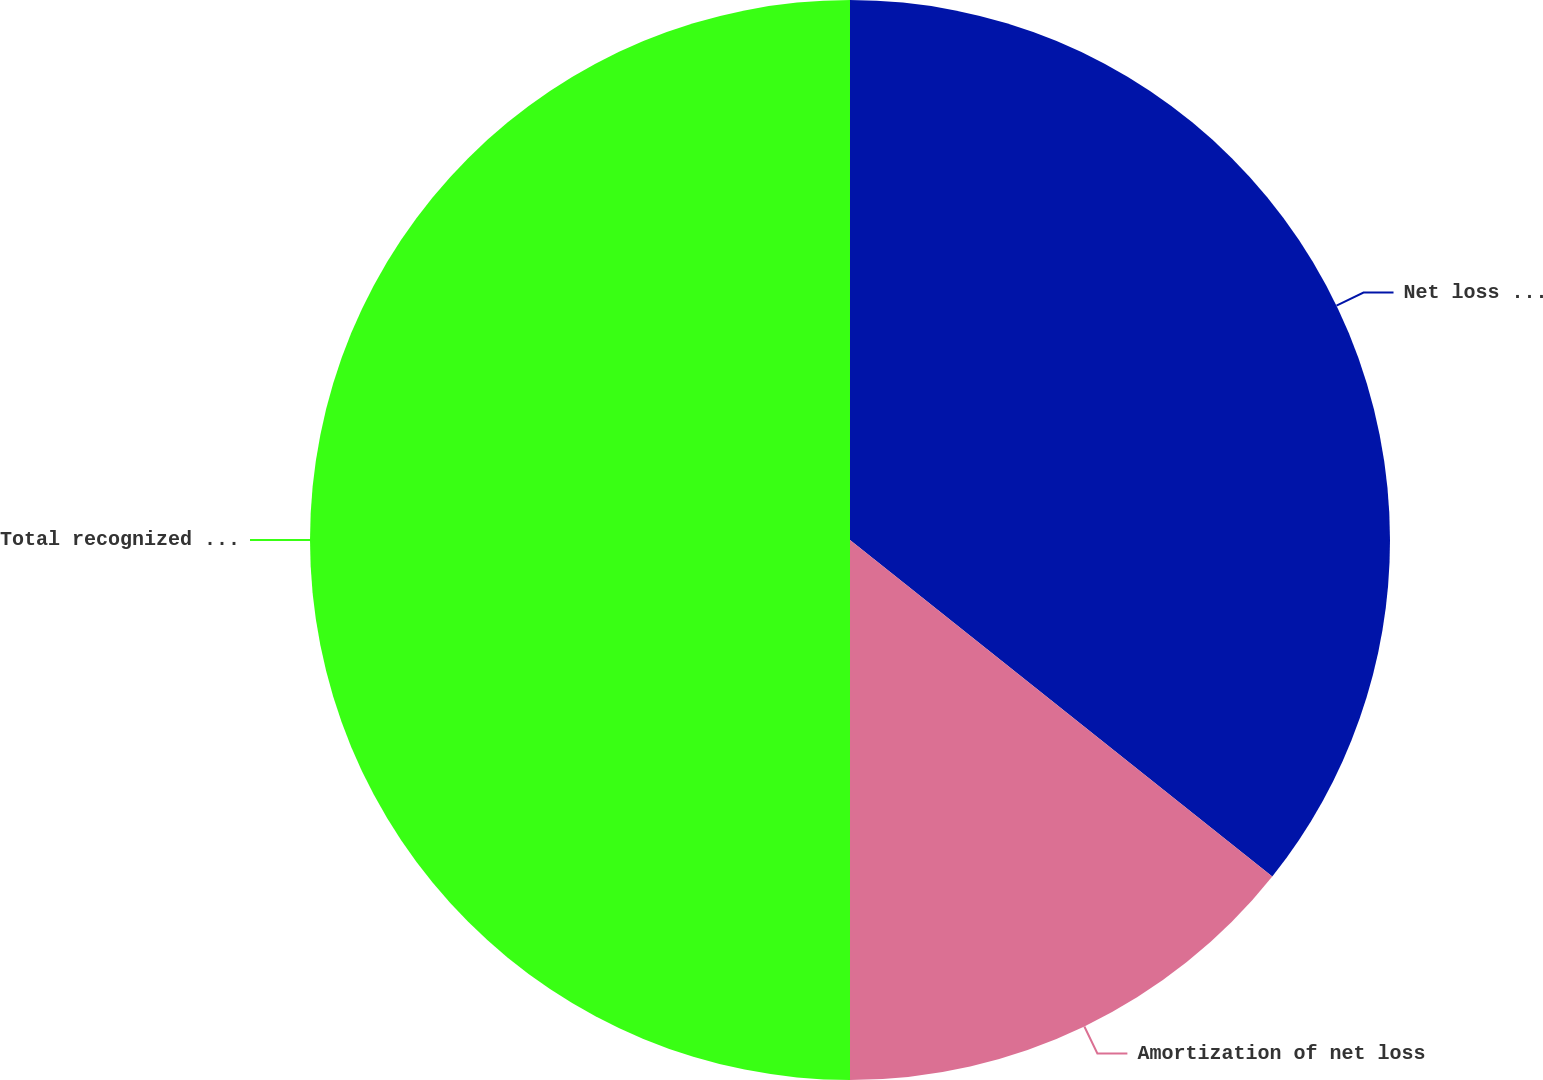Convert chart. <chart><loc_0><loc_0><loc_500><loc_500><pie_chart><fcel>Net loss (gain)<fcel>Amortization of net loss<fcel>Total recognized in other<nl><fcel>35.71%<fcel>14.29%<fcel>50.0%<nl></chart> 